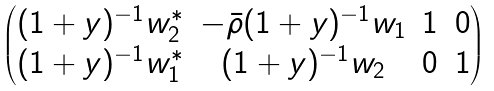Convert formula to latex. <formula><loc_0><loc_0><loc_500><loc_500>\begin{pmatrix} ( 1 + y ) ^ { - 1 } w _ { 2 } ^ { * } & - \bar { \rho } ( 1 + y ) ^ { - 1 } w _ { 1 } & 1 & 0 \\ ( 1 + y ) ^ { - 1 } w _ { 1 } ^ { * } & ( 1 + y ) ^ { - 1 } w _ { 2 } & 0 & 1 \end{pmatrix}</formula> 